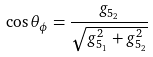<formula> <loc_0><loc_0><loc_500><loc_500>\cos \theta _ { \phi } = \frac { g _ { 5 _ { 2 } } } { \sqrt { g _ { 5 _ { 1 } } ^ { 2 } + g _ { 5 _ { 2 } } ^ { 2 } } }</formula> 